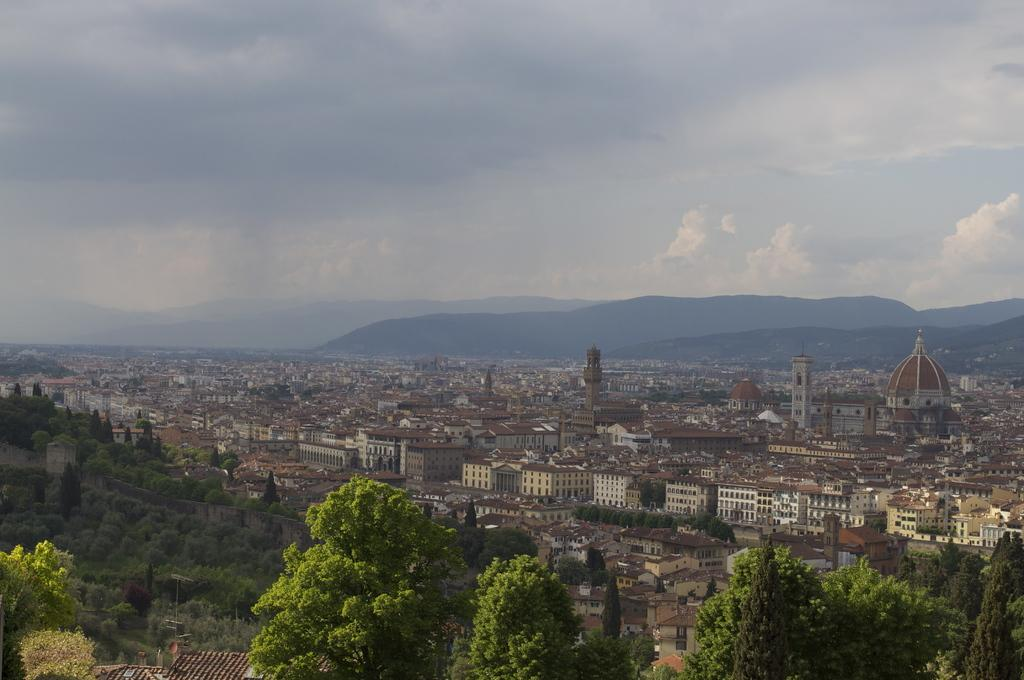What type of view is shown in the image? The image is an aerial view of a city. What natural elements can be seen in the image? There are trees and plants visible in the image. What man-made structures can be seen in the image? There are houses, buildings, and palaces visible in the image. What geographical feature is visible in the background of the image? There is a hill visible in the background of the image. What can be seen in the sky in the background of the image? There are clouds visible in the sky in the background of the image. Where is the stream located in the image? There is no stream present in the image. What type of vest is being worn by the palace in the image? There are no people or clothing items visible in the image, as it features an aerial view of a city with various structures and geographical features. What appliance is being used to clean the windows of the buildings in the image? There is no appliance visible in the image, as it is an aerial view and does not focus on specific activities or objects. 